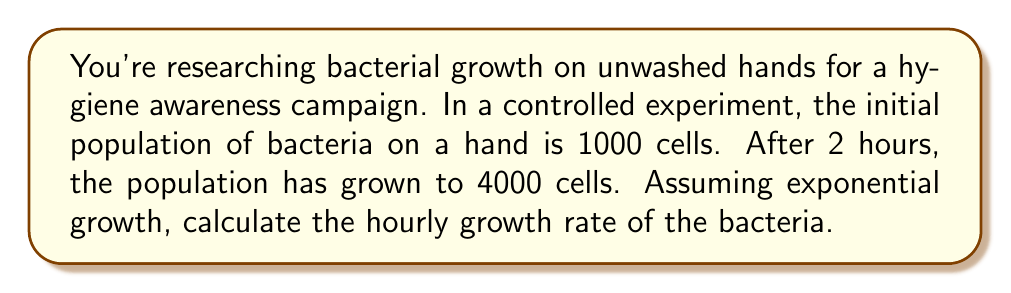What is the answer to this math problem? Let's approach this step-by-step using logarithmic equations:

1) The exponential growth equation is:
   $$N(t) = N_0 \cdot e^{rt}$$
   where $N(t)$ is the population at time $t$, $N_0$ is the initial population, $r$ is the growth rate, and $t$ is time.

2) We know:
   $N_0 = 1000$ (initial population)
   $N(2) = 4000$ (population after 2 hours)
   $t = 2$ hours

3) Substituting these values into the equation:
   $$4000 = 1000 \cdot e^{2r}$$

4) Dividing both sides by 1000:
   $$4 = e^{2r}$$

5) Taking the natural logarithm of both sides:
   $$\ln(4) = \ln(e^{2r})$$

6) Simplify the right side using the logarithm property $\ln(e^x) = x$:
   $$\ln(4) = 2r$$

7) Solve for $r$:
   $$r = \frac{\ln(4)}{2}$$

8) Calculate:
   $$r = \frac{\ln(4)}{2} \approx 0.6931$$

Therefore, the hourly growth rate is approximately 0.6931 or 69.31%.
Answer: $0.6931$ per hour 